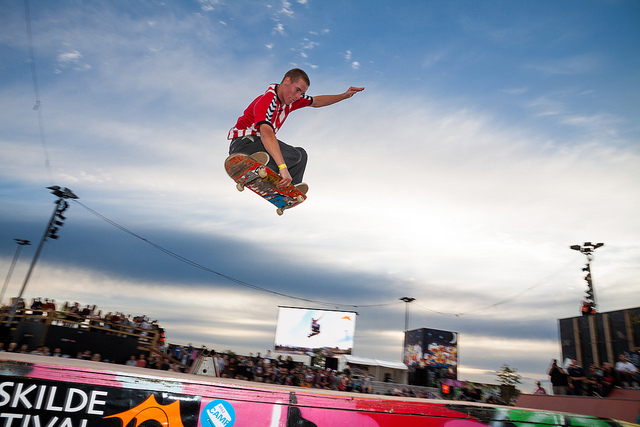What kind of skateboarding event could this be, and can you tell anything about where or when it is taking place based on the image? Based on the image, this appears to be a competitive or exhibition skateboarding event, given the presence of ramps, audience, and the focused performance of the skateboarder in action. The banners and branding around the ramp suggest sponsorship and organization, typical of skateboarding competitions or festivals. While the specific location and date are not ascertainable from the image alone, the clothing of the spectators and the skateboarder suggest it's during a warmer season. 